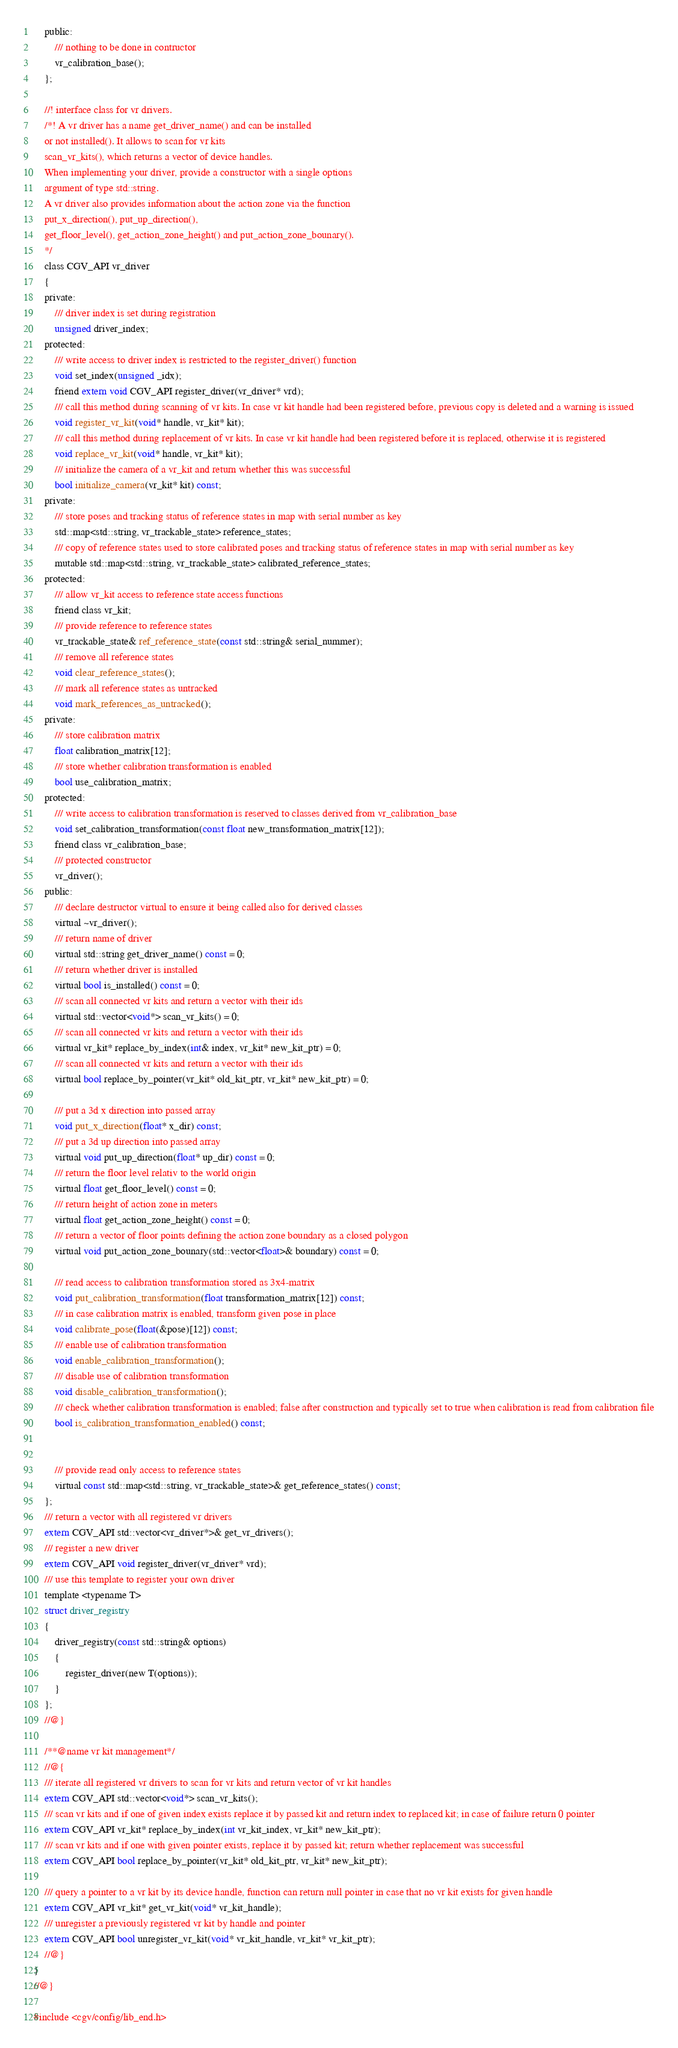<code> <loc_0><loc_0><loc_500><loc_500><_C_>	public:
		/// nothing to be done in contructor
		vr_calibration_base();
	};

	//! interface class for vr drivers.
	/*!	A vr driver has a name get_driver_name() and can be installed 
	or not installed(). It allows to scan for vr kits 
	scan_vr_kits(), which returns a vector of device handles.
	When implementing your driver, provide a constructor with a single options 
	argument of type std::string.
	A vr driver also provides information about the action zone via the function
	put_x_direction(), put_up_direction(), 
	get_floor_level(), get_action_zone_height() and put_action_zone_bounary().
	*/
	class CGV_API vr_driver
	{
	private:
		/// driver index is set during registration
		unsigned driver_index;
	protected:
		/// write access to driver index is restricted to the register_driver() function
		void set_index(unsigned _idx);
		friend extern void CGV_API register_driver(vr_driver* vrd);
		/// call this method during scanning of vr kits. In case vr kit handle had been registered before, previous copy is deleted and a warning is issued
		void register_vr_kit(void* handle, vr_kit* kit);
		/// call this method during replacement of vr kits. In case vr kit handle had been registered before it is replaced, otherwise it is registered
		void replace_vr_kit(void* handle, vr_kit* kit);
		/// initialize the camera of a vr_kit and return whether this was successful
		bool initialize_camera(vr_kit* kit) const;
	private:
		/// store poses and tracking status of reference states in map with serial number as key
		std::map<std::string, vr_trackable_state> reference_states;
		/// copy of reference states used to store calibrated poses and tracking status of reference states in map with serial number as key
		mutable std::map<std::string, vr_trackable_state> calibrated_reference_states;
	protected:
		/// allow vr_kit access to reference state access functions
		friend class vr_kit;
		/// provide reference to reference states
		vr_trackable_state& ref_reference_state(const std::string& serial_nummer);
		/// remove all reference states
		void clear_reference_states();
		/// mark all reference states as untracked
		void mark_references_as_untracked();
	private:
		/// store calibration matrix
		float calibration_matrix[12];
		/// store whether calibration transformation is enabled
		bool use_calibration_matrix;
	protected:
		/// write access to calibration transformation is reserved to classes derived from vr_calibration_base
		void set_calibration_transformation(const float new_transformation_matrix[12]);
		friend class vr_calibration_base;
		/// protected constructor
		vr_driver();
	public:
		/// declare destructor virtual to ensure it being called also for derived classes
		virtual ~vr_driver();
		/// return name of driver
		virtual std::string get_driver_name() const = 0;
		/// return whether driver is installed
		virtual bool is_installed() const = 0;
		/// scan all connected vr kits and return a vector with their ids
		virtual std::vector<void*> scan_vr_kits() = 0;
		/// scan all connected vr kits and return a vector with their ids
		virtual vr_kit* replace_by_index(int& index, vr_kit* new_kit_ptr) = 0;
		/// scan all connected vr kits and return a vector with their ids
		virtual bool replace_by_pointer(vr_kit* old_kit_ptr, vr_kit* new_kit_ptr) = 0;

		/// put a 3d x direction into passed array
		void put_x_direction(float* x_dir) const;
		/// put a 3d up direction into passed array
		virtual void put_up_direction(float* up_dir) const = 0;
		/// return the floor level relativ to the world origin
		virtual float get_floor_level() const = 0;
		/// return height of action zone in meters
		virtual float get_action_zone_height() const = 0;
		/// return a vector of floor points defining the action zone boundary as a closed polygon
		virtual void put_action_zone_bounary(std::vector<float>& boundary) const = 0;

		/// read access to calibration transformation stored as 3x4-matrix
		void put_calibration_transformation(float transformation_matrix[12]) const;
		/// in case calibration matrix is enabled, transform given pose in place
		void calibrate_pose(float(&pose)[12]) const;
		/// enable use of calibration transformation 
		void enable_calibration_transformation();
		/// disable use of calibration transformation
		void disable_calibration_transformation();
		/// check whether calibration transformation is enabled; false after construction and typically set to true when calibration is read from calibration file
		bool is_calibration_transformation_enabled() const;


		/// provide read only access to reference states
		virtual const std::map<std::string, vr_trackable_state>& get_reference_states() const;
	};
	/// return a vector with all registered vr drivers
	extern CGV_API std::vector<vr_driver*>& get_vr_drivers();
	/// register a new driver
	extern CGV_API void register_driver(vr_driver* vrd);
	/// use this template to register your own driver
	template <typename T>
	struct driver_registry
	{
		driver_registry(const std::string& options)
		{
			register_driver(new T(options));
		}
	};
	//@}

	/**@name vr kit management*/
	//@{
	/// iterate all registered vr drivers to scan for vr kits and return vector of vr kit handles
	extern CGV_API std::vector<void*> scan_vr_kits();
	/// scan vr kits and if one of given index exists replace it by passed kit and return index to replaced kit; in case of failure return 0 pointer
	extern CGV_API vr_kit* replace_by_index(int vr_kit_index, vr_kit* new_kit_ptr);
	/// scan vr kits and if one with given pointer exists, replace it by passed kit; return whether replacement was successful
	extern CGV_API bool replace_by_pointer(vr_kit* old_kit_ptr, vr_kit* new_kit_ptr);

	/// query a pointer to a vr kit by its device handle, function can return null pointer in case that no vr kit exists for given handle
	extern CGV_API vr_kit* get_vr_kit(void* vr_kit_handle);
	/// unregister a previously registered vr kit by handle and pointer
	extern CGV_API bool unregister_vr_kit(void* vr_kit_handle, vr_kit* vr_kit_ptr);
	//@}
}
//@}

#include <cgv/config/lib_end.h>
</code> 